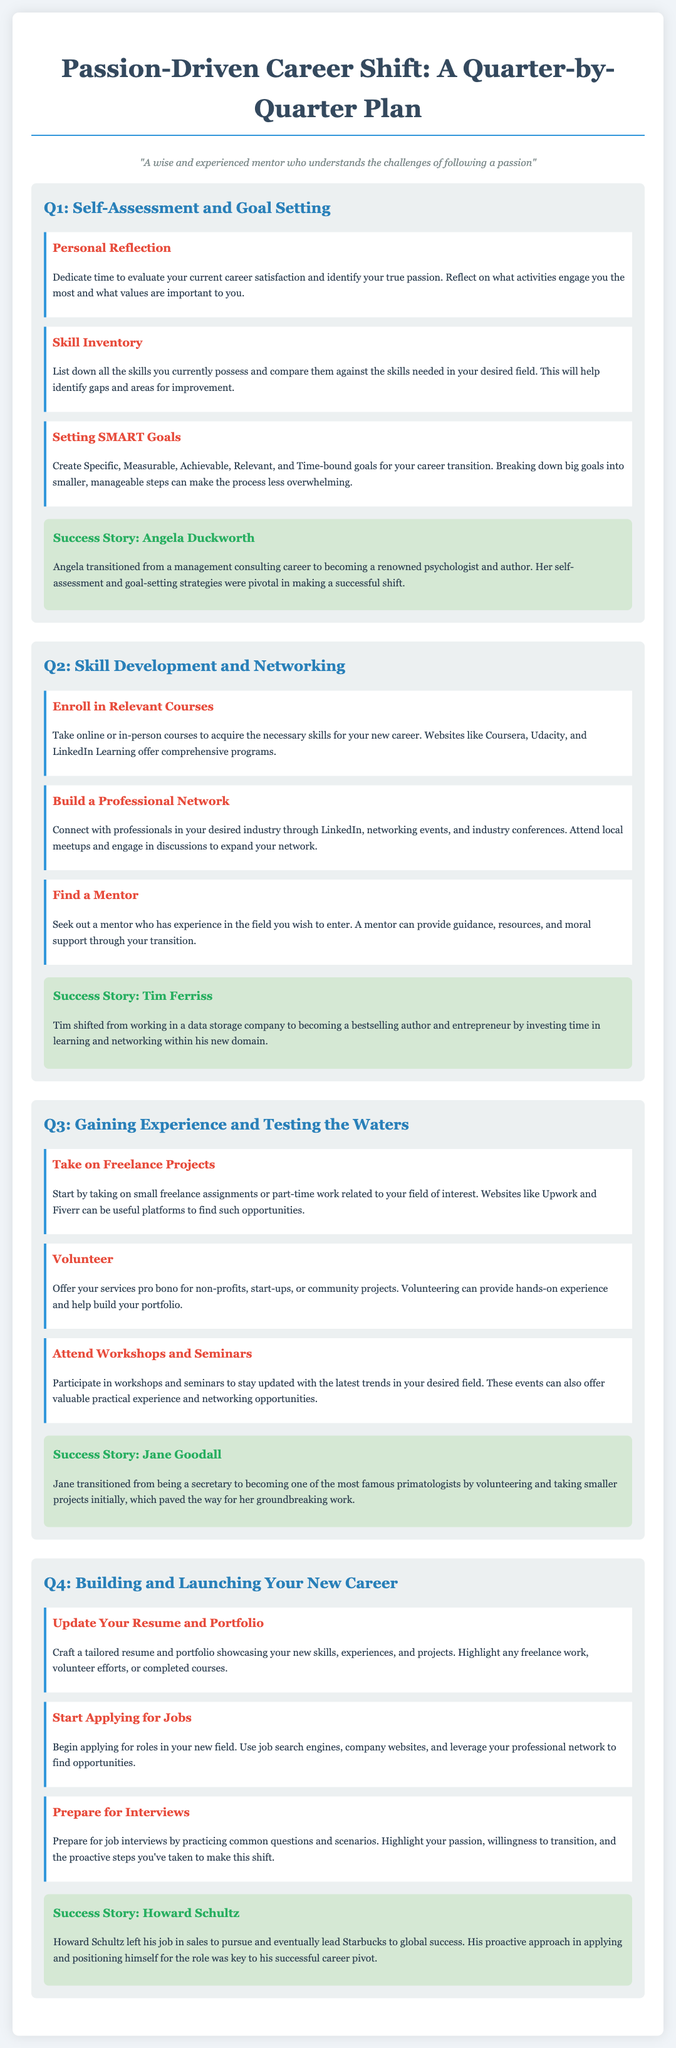What is the title of the document? The title of the document is prominently displayed at the top and reflects its content, which focuses on a structured plan for career transition.
Answer: Passion-Driven Career Shift: A Quarter-by-Quarter Plan Who is mentioned in the success story for Q1? The success story in Q1 highlights Angela Duckworth's career transition, making it a key example of success in this phase.
Answer: Angela Duckworth What type of goals should be set according to Q1? Q1 emphasizes the need to create goals that are specific to ensure clarity and focus during the career transition process.
Answer: SMART Goals What activity is suggested in Q3 to gain practical experience? The activities listed in Q3 involve taking on freelance projects, which provides real-world experience relevant to the new career path.
Answer: Take on Freelance Projects Which quarter emphasizes networking? The document clearly outlines networking as an essential activity in the second quarter of the plan, indicating its importance early in the transition.
Answer: Q2 How many success stories are included in the document? The number of success stories scattered throughout the document provides inspiration and examples of others who have made similar transitions.
Answer: Four What is one key action to take in Q4? Q4 outlines a vital action to update necessary professional documents as part of preparing for the job application process.
Answer: Update Your Resume and Portfolio In which quarter should you find a mentor? The specific activities recommended in Q2 stress the importance of mentorship during early stages of the career transition, making this action relevant to that quarter.
Answer: Q2 